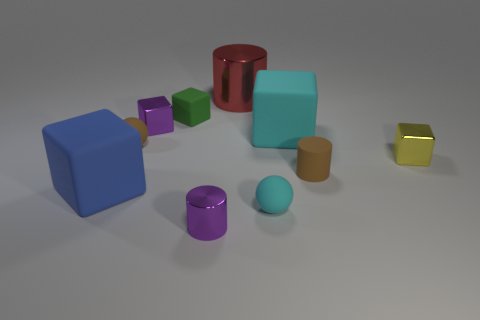Subtract 2 cubes. How many cubes are left? 3 Subtract all gray blocks. Subtract all purple balls. How many blocks are left? 5 Subtract all balls. How many objects are left? 8 Add 1 large red metallic things. How many large red metallic things are left? 2 Add 3 cyan matte spheres. How many cyan matte spheres exist? 4 Subtract 1 yellow blocks. How many objects are left? 9 Subtract all small purple shiny blocks. Subtract all tiny objects. How many objects are left? 2 